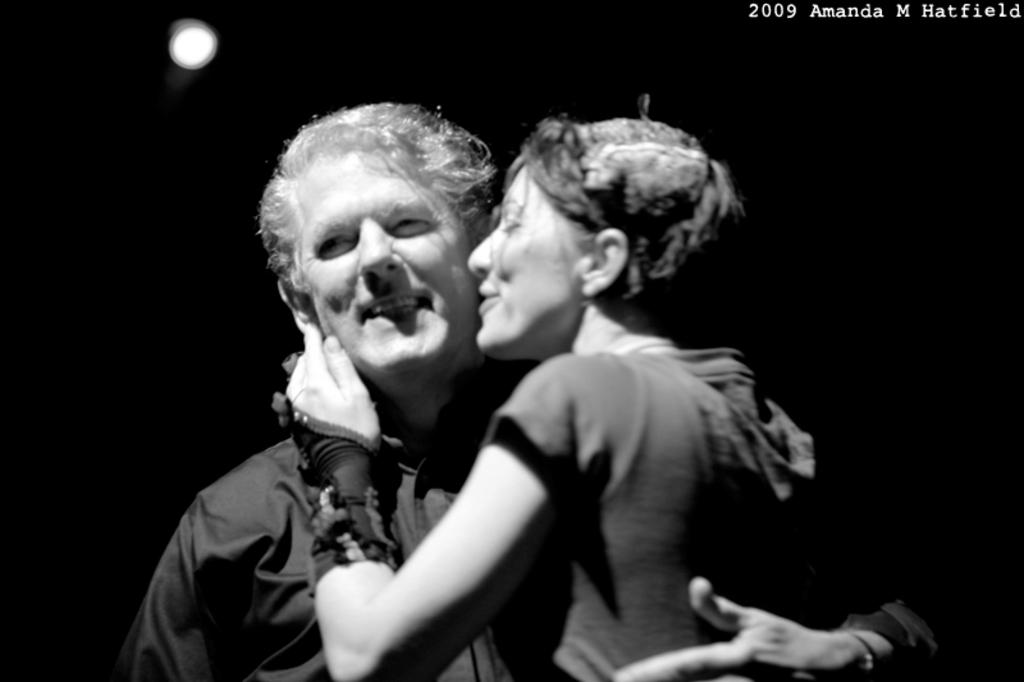What is the color scheme of the image? The image is black and white. What is happening between the man and the woman in the image? The man is holding the woman in the image. Is there any text present in the image? Yes, there is text in the top right corner of the image. What is the title of the book the man is reading in the image? There is no book or reading material present in the image. What is the profit margin of the company mentioned in the text in the image? There is no mention of a company or profit margin in the image. 